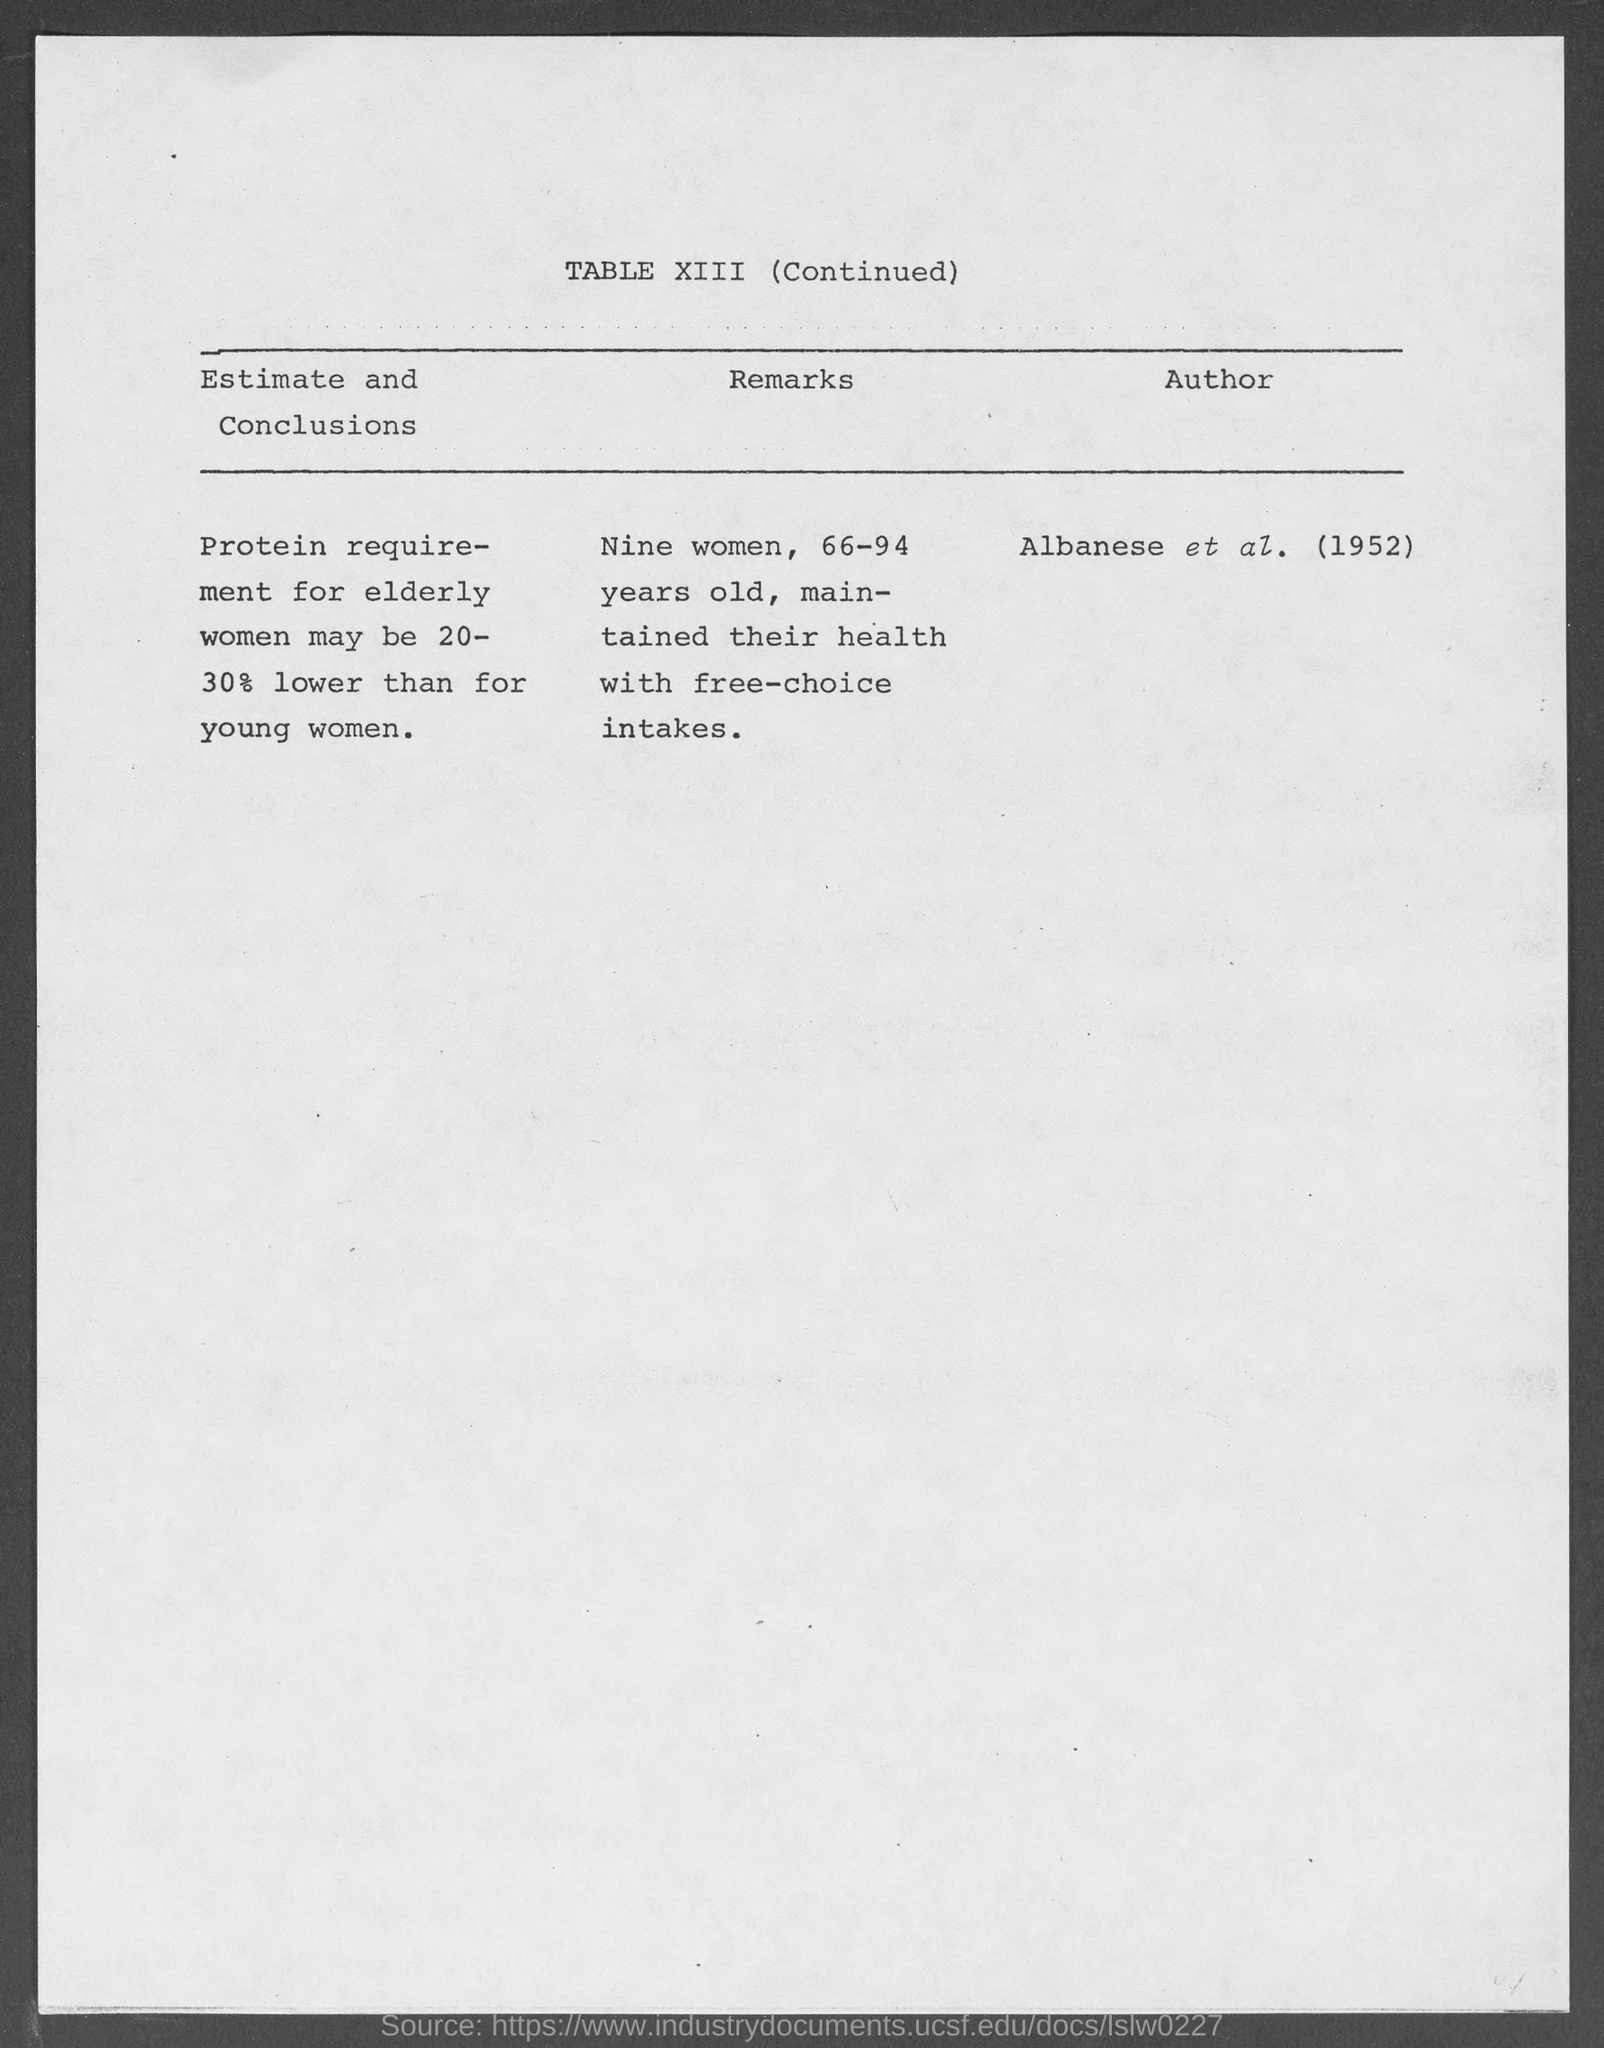What is the table no.?
Offer a very short reply. Table xiii (continued). 